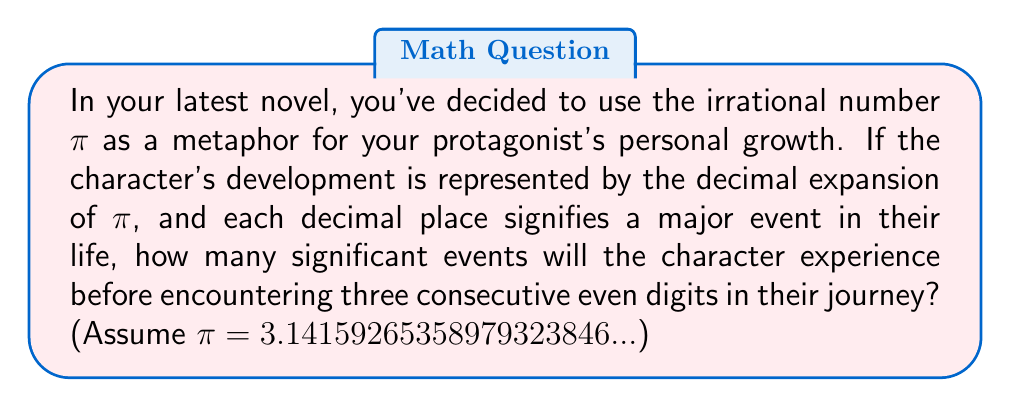Could you help me with this problem? To solve this problem, we need to examine the decimal expansion of $\pi$ and count the digits until we encounter three consecutive even digits. Let's break it down step-by-step:

1) First, let's write out the decimal expansion of $\pi$ and mark the even digits:
   $3.\underline{1}4\underline{1}59\underline{2}6535897932384\underline{6}...$

2) Now, let's go through the digits one by one, looking for three consecutive even digits:

   - 3 (odd)
   - 1 (odd)
   - 4 (even) - count: 1
   - 1 (odd) - reset count to 0
   - 5 (odd)
   - 9 (odd)
   - 2 (even) - count: 1
   - 6 (even) - count: 2
   - 5 (odd) - reset count to 0
   - 3 (odd)
   - 5 (odd)
   - 8 (even) - count: 1
   - 9 (odd) - reset count to 0
   - 7 (odd)
   - 9 (odd)
   - 3 (odd)
   - 2 (even) - count: 1
   - 3 (odd) - reset count to 0
   - 8 (even) - count: 1
   - 4 (even) - count: 2
   - 6 (even) - count: 3

3) We stop at the 21st decimal place because we've found three consecutive even digits (4, 6, 8).

4) To get the total number of events, we need to count the digits from the beginning of the decimal expansion (including the 3 before the decimal point) up to and including the last digit of our three consecutive even digits.

5) Therefore, the total count is 1 (for the 3) + 21 (decimal places) = 22.

This means the character will experience 22 significant events before reaching a point in their journey represented by three consecutive even digits in the decimal expansion of $\pi$.
Answer: 22 significant events 